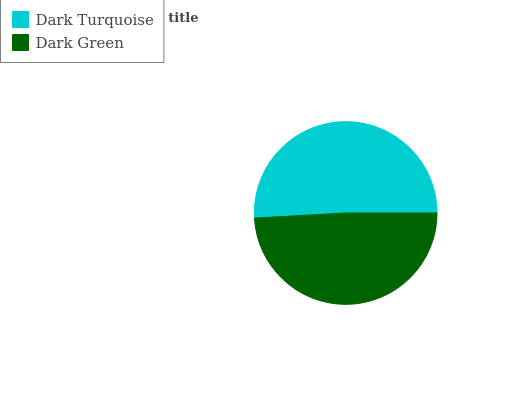Is Dark Green the minimum?
Answer yes or no. Yes. Is Dark Turquoise the maximum?
Answer yes or no. Yes. Is Dark Green the maximum?
Answer yes or no. No. Is Dark Turquoise greater than Dark Green?
Answer yes or no. Yes. Is Dark Green less than Dark Turquoise?
Answer yes or no. Yes. Is Dark Green greater than Dark Turquoise?
Answer yes or no. No. Is Dark Turquoise less than Dark Green?
Answer yes or no. No. Is Dark Turquoise the high median?
Answer yes or no. Yes. Is Dark Green the low median?
Answer yes or no. Yes. Is Dark Green the high median?
Answer yes or no. No. Is Dark Turquoise the low median?
Answer yes or no. No. 